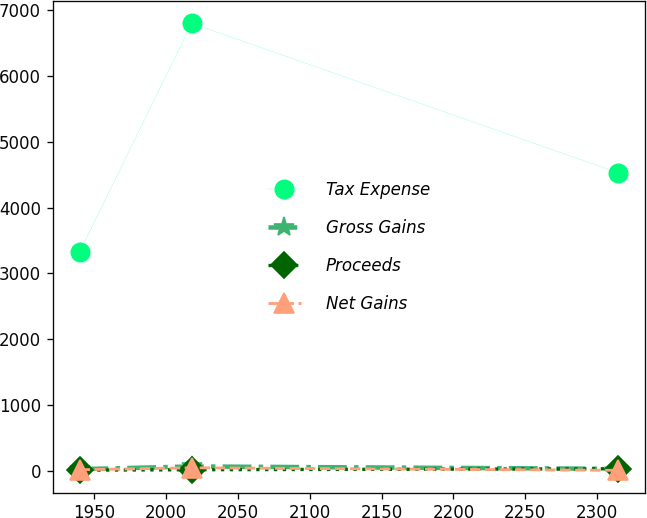Convert chart to OTSL. <chart><loc_0><loc_0><loc_500><loc_500><line_chart><ecel><fcel>Tax Expense<fcel>Gross Gains<fcel>Proceeds<fcel>Net Gains<nl><fcel>1939.85<fcel>3323.75<fcel>22<fcel>7.09<fcel>13.39<nl><fcel>2017.91<fcel>6802.2<fcel>63.2<fcel>13.48<fcel>42.73<nl><fcel>2314.52<fcel>4529.63<fcel>27.04<fcel>28.06<fcel>4.56<nl></chart> 